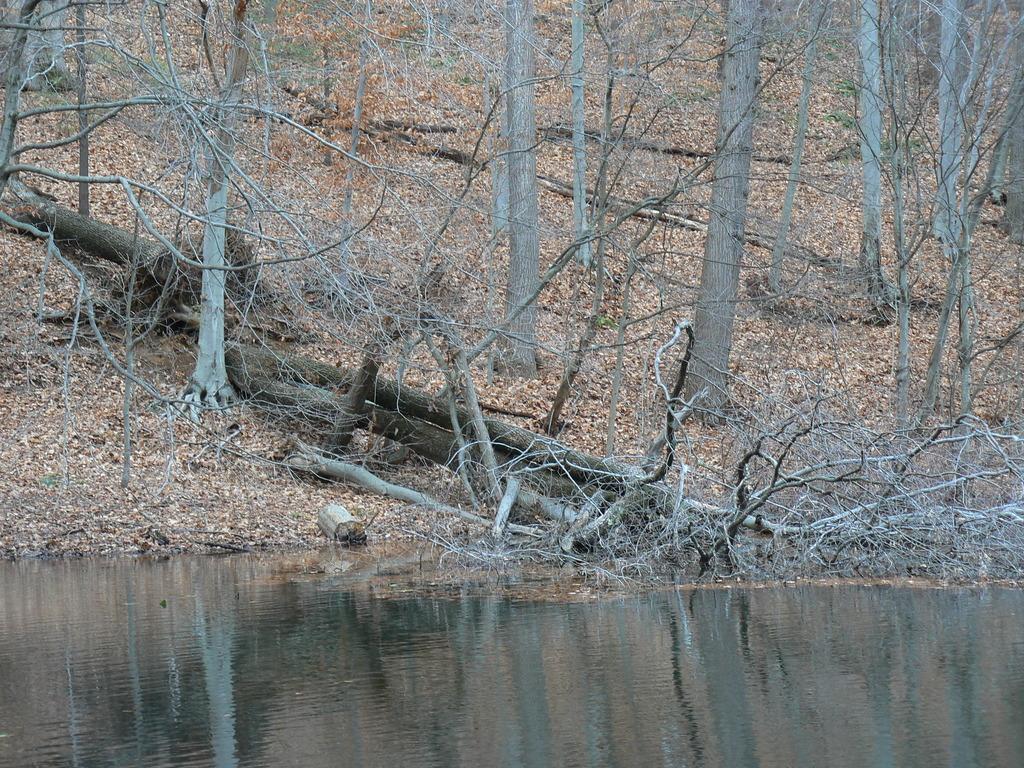In one or two sentences, can you explain what this image depicts? In this image we can see water, branches and trees. 